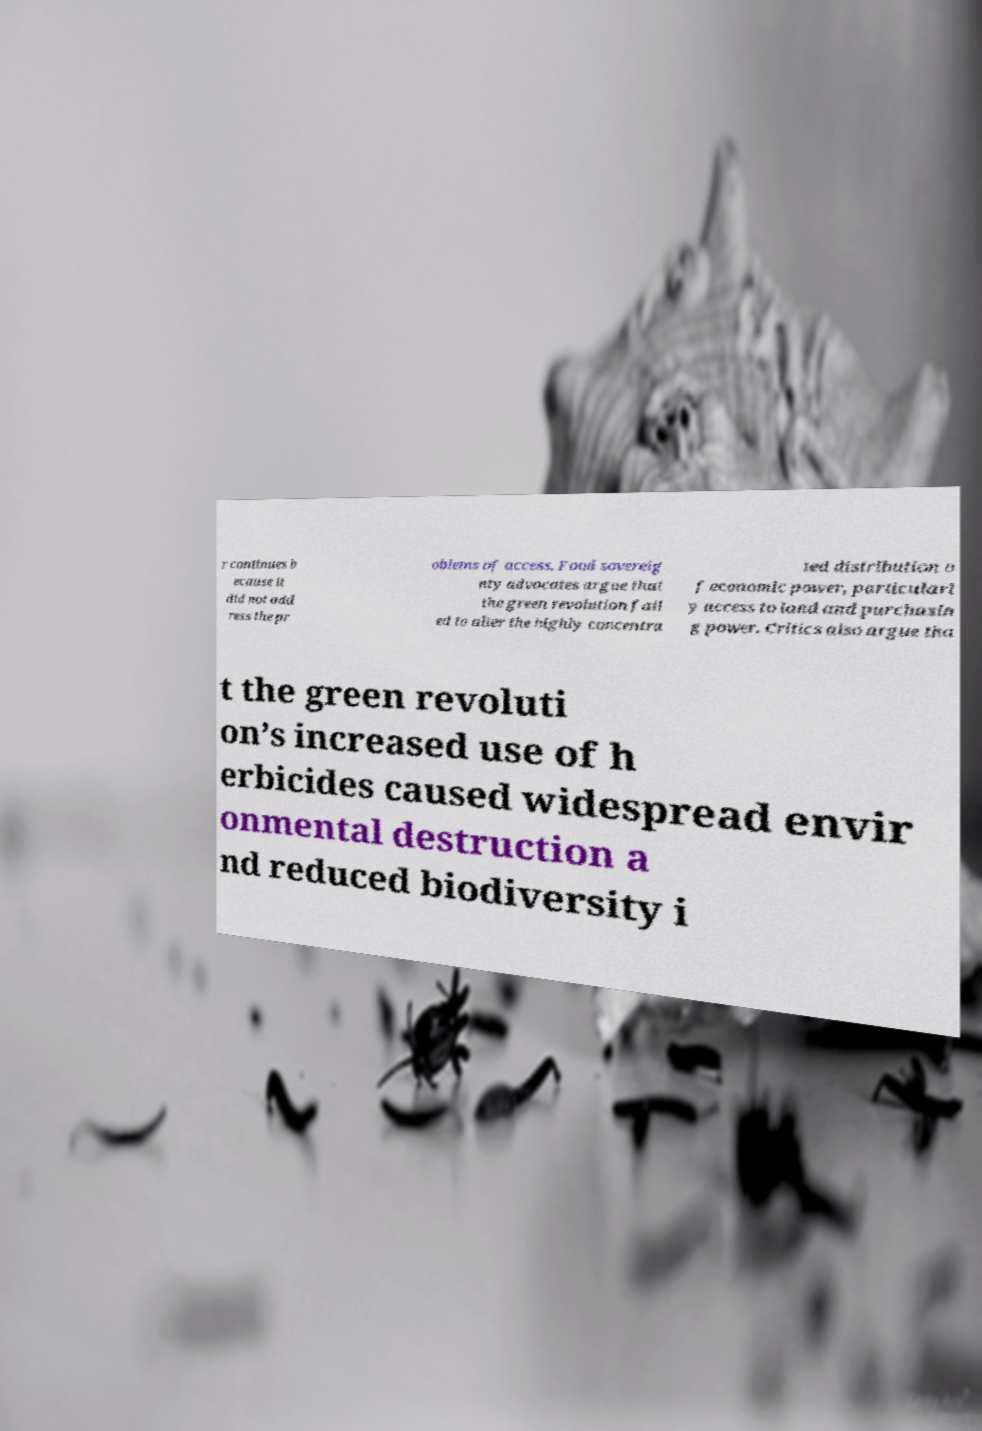I need the written content from this picture converted into text. Can you do that? r continues b ecause it did not add ress the pr oblems of access. Food sovereig nty advocates argue that the green revolution fail ed to alter the highly concentra ted distribution o f economic power, particularl y access to land and purchasin g power. Critics also argue tha t the green revoluti on’s increased use of h erbicides caused widespread envir onmental destruction a nd reduced biodiversity i 